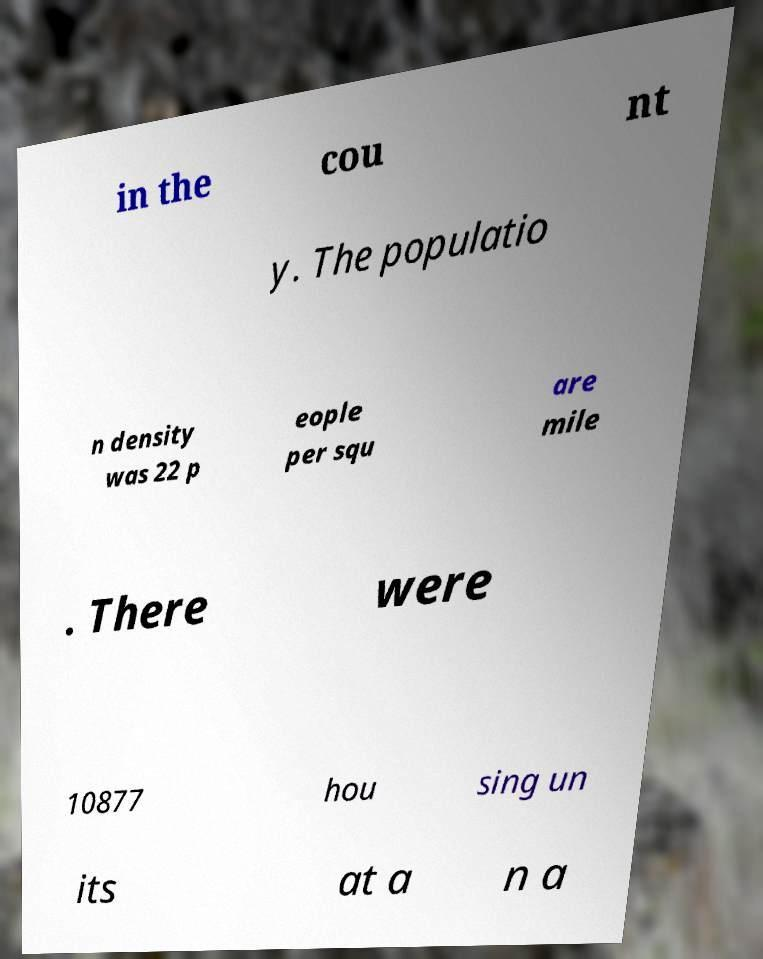Please identify and transcribe the text found in this image. in the cou nt y. The populatio n density was 22 p eople per squ are mile . There were 10877 hou sing un its at a n a 